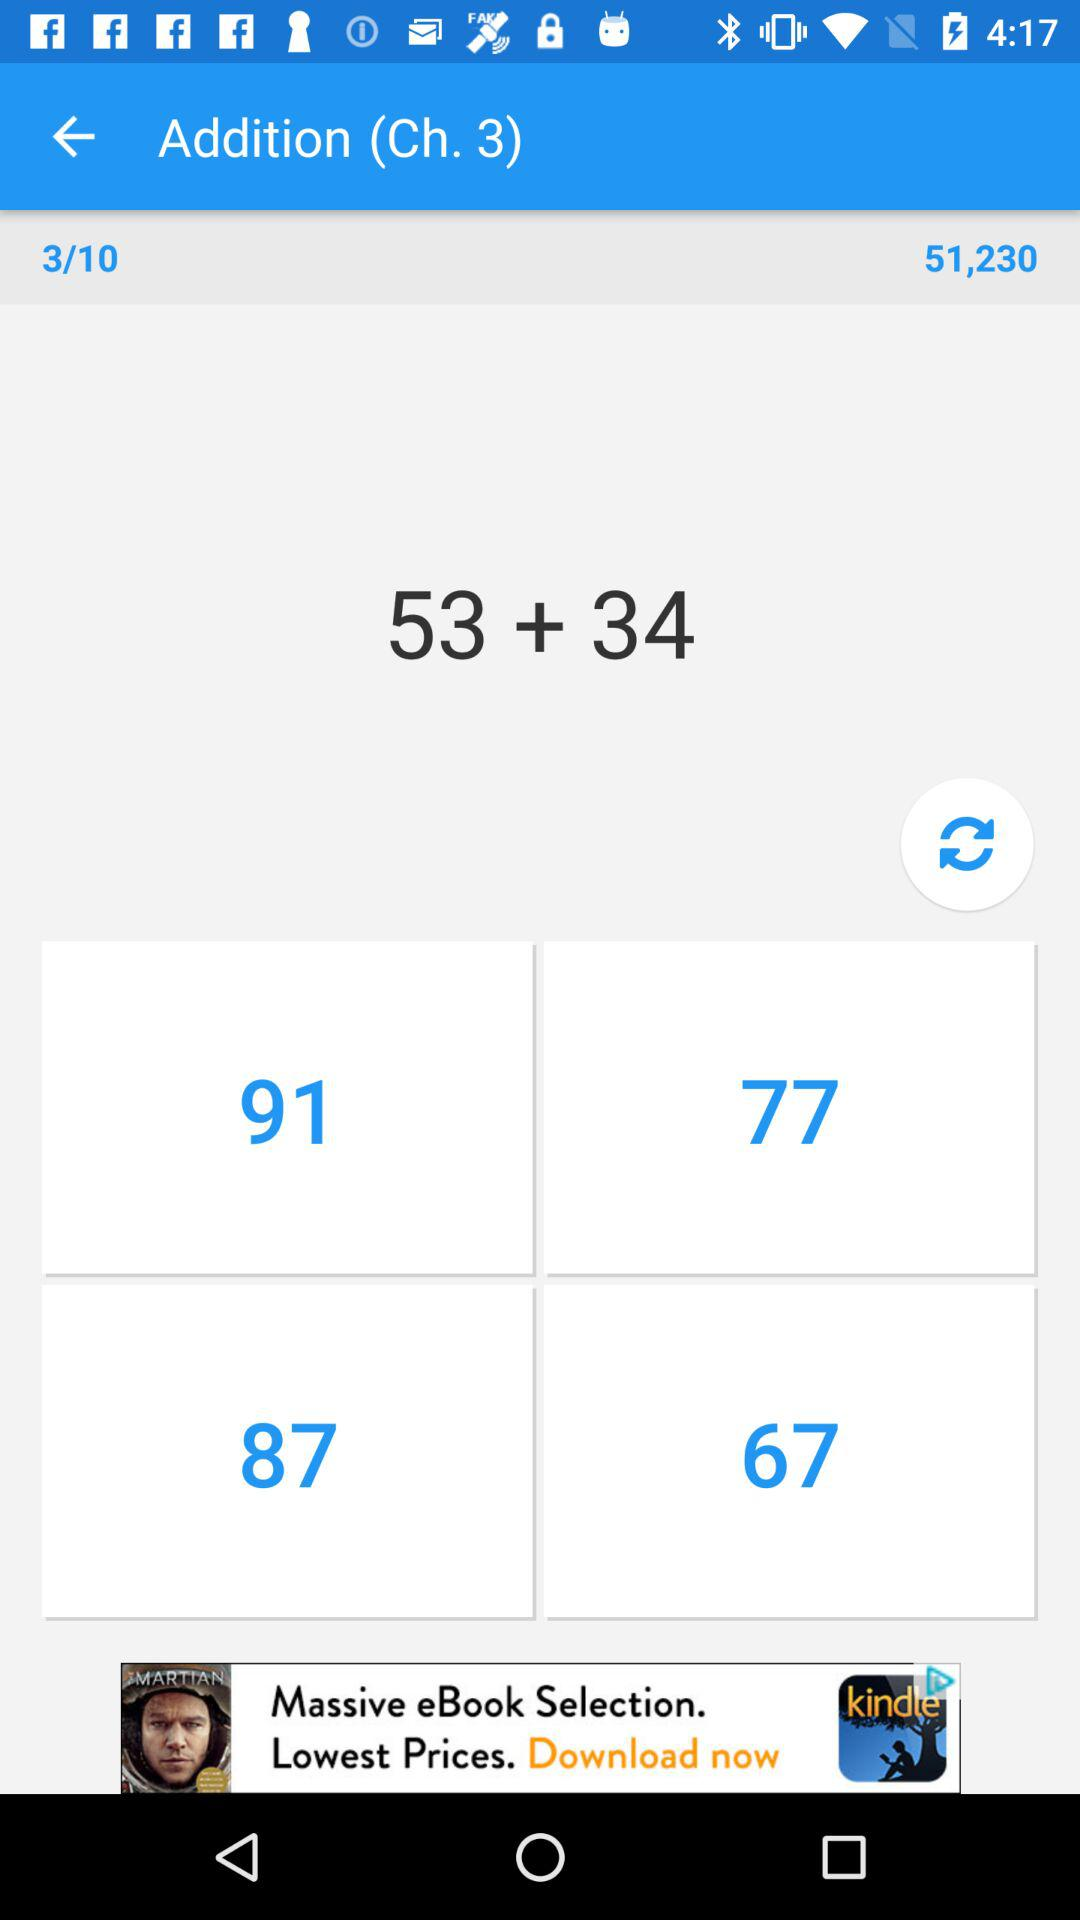Which topic is mentioned? The topic "Addition" is mentioned. 